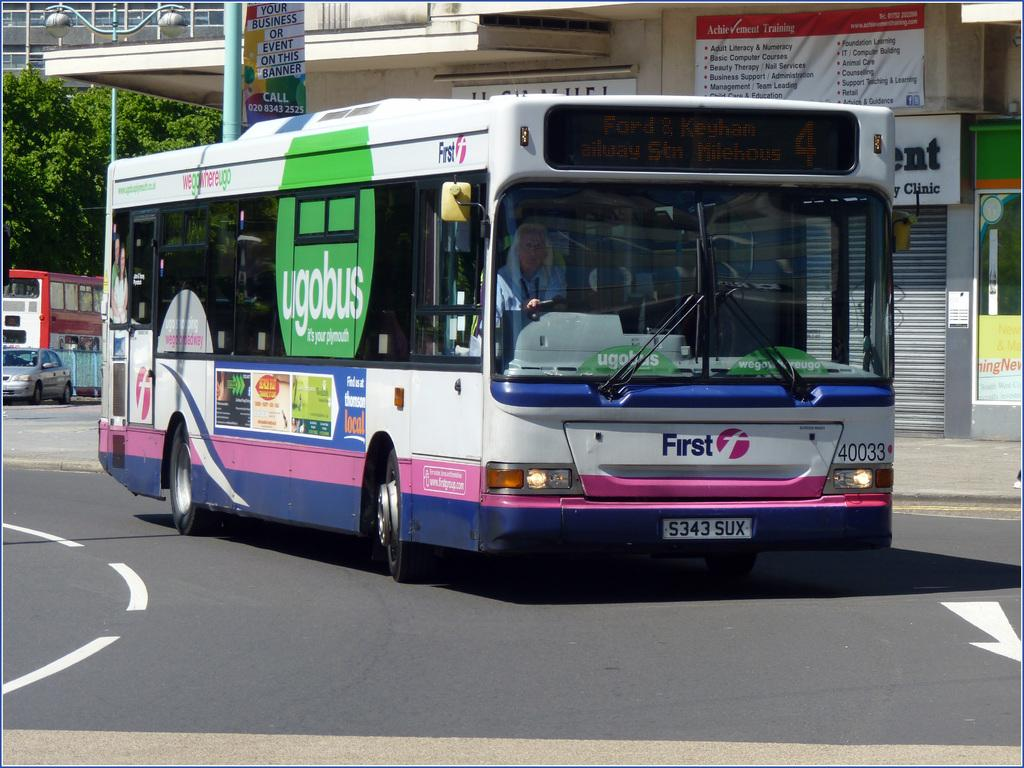Provide a one-sentence caption for the provided image. A city bus that says first on the very front driving down a city street. 